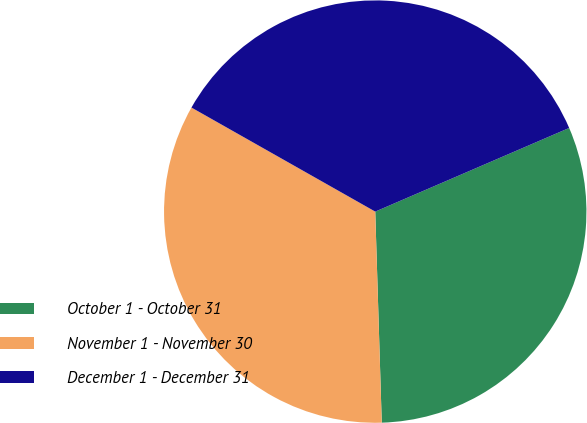<chart> <loc_0><loc_0><loc_500><loc_500><pie_chart><fcel>October 1 - October 31<fcel>November 1 - November 30<fcel>December 1 - December 31<nl><fcel>30.99%<fcel>33.69%<fcel>35.32%<nl></chart> 